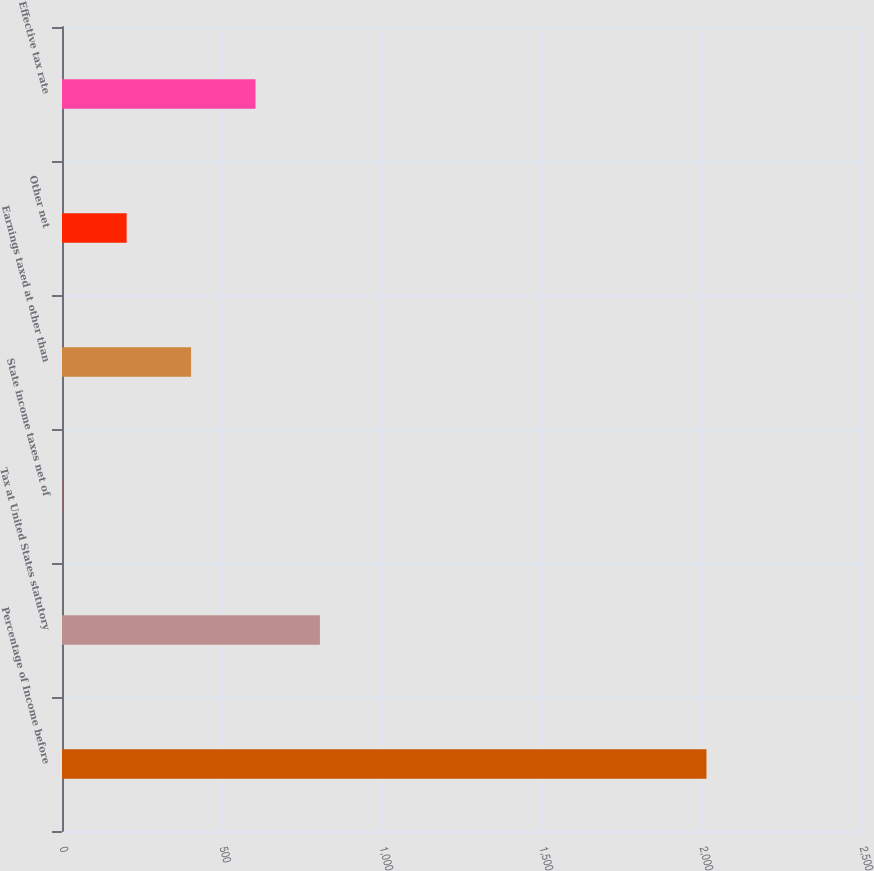Convert chart. <chart><loc_0><loc_0><loc_500><loc_500><bar_chart><fcel>Percentage of Income before<fcel>Tax at United States statutory<fcel>State income taxes net of<fcel>Earnings taxed at other than<fcel>Other net<fcel>Effective tax rate<nl><fcel>2014<fcel>806.02<fcel>0.7<fcel>403.36<fcel>202.03<fcel>604.69<nl></chart> 